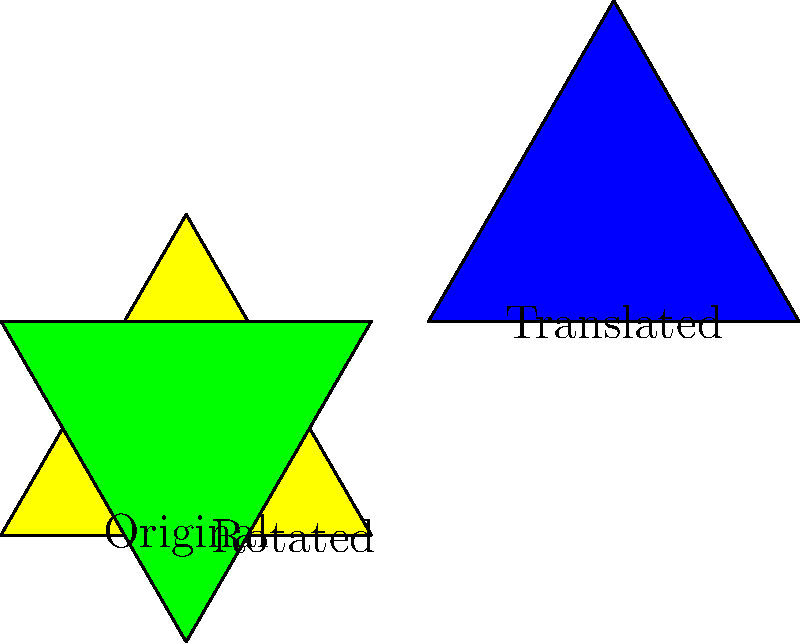In the image above, three triangular religious icons are shown. The green icon is rotated 60° clockwise from the original yellow icon, and the blue icon is translated 2 units right and 1 unit up from the original. Which transformation(s) would make the blue icon congruent to the green icon? To determine the transformation(s) needed to make the blue icon congruent to the green icon, we need to follow these steps:

1. Observe that the blue icon is already the same size and shape as the original yellow icon and the green icon, due to the properties of translation.

2. The blue icon needs to be in the same position and orientation as the green icon to be congruent.

3. To achieve this, we need to:
   a) First, rotate the blue icon 60° clockwise around its center to match the orientation of the green icon.
   b) Then, translate the rotated blue icon to the position of the green icon.

4. The translation vector can be calculated as follows:
   - The green icon's center is at (cos(60°), sin(60°)) ≈ (0.5, 0.866)
   - The blue icon's center is at (2, 1)
   - The translation vector is (0.5 - 2, 0.866 - 1) ≈ (-1.5, -0.134)

5. Therefore, the complete transformation would be:
   a) Rotate 60° clockwise around the center of the blue icon
   b) Translate by the vector (-1.5, -0.134)
Answer: Rotate 60° clockwise, then translate by $(-1.5, -0.134)$ 